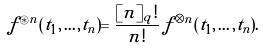Convert formula to latex. <formula><loc_0><loc_0><loc_500><loc_500>f ^ { \circledast n } ( t _ { 1 } , \dots , t _ { n } ) = \frac { [ n ] _ { q } ! } { n ! } \, f ^ { \otimes n } ( t _ { 1 } , \dots , t _ { n } ) .</formula> 